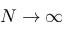<formula> <loc_0><loc_0><loc_500><loc_500>N \rightarrow \infty</formula> 